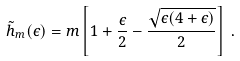Convert formula to latex. <formula><loc_0><loc_0><loc_500><loc_500>\tilde { h } _ { m } ( \epsilon ) = m \left [ 1 + \frac { \epsilon } { 2 } - \frac { \sqrt { \epsilon ( 4 + \epsilon ) } } { 2 } \right ] \, .</formula> 